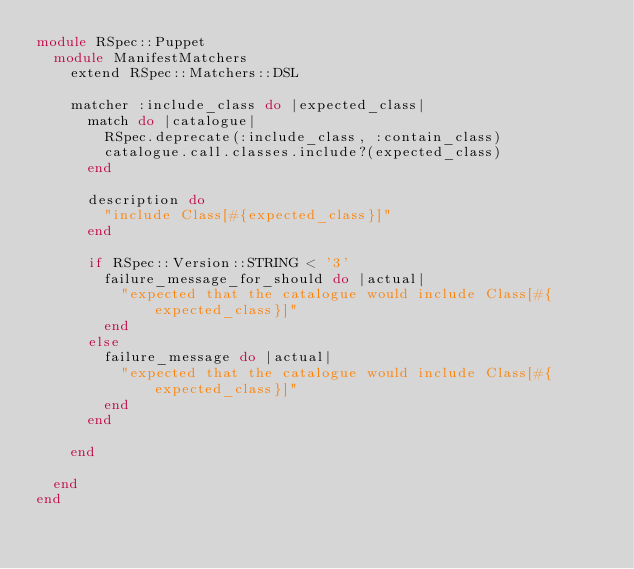<code> <loc_0><loc_0><loc_500><loc_500><_Ruby_>module RSpec::Puppet
  module ManifestMatchers
    extend RSpec::Matchers::DSL

    matcher :include_class do |expected_class|
      match do |catalogue|
        RSpec.deprecate(:include_class, :contain_class)
        catalogue.call.classes.include?(expected_class)
      end

      description do
        "include Class[#{expected_class}]"
      end

      if RSpec::Version::STRING < '3'
        failure_message_for_should do |actual|
          "expected that the catalogue would include Class[#{expected_class}]"
        end
      else
        failure_message do |actual|
          "expected that the catalogue would include Class[#{expected_class}]"
        end
      end

    end

  end
end
</code> 